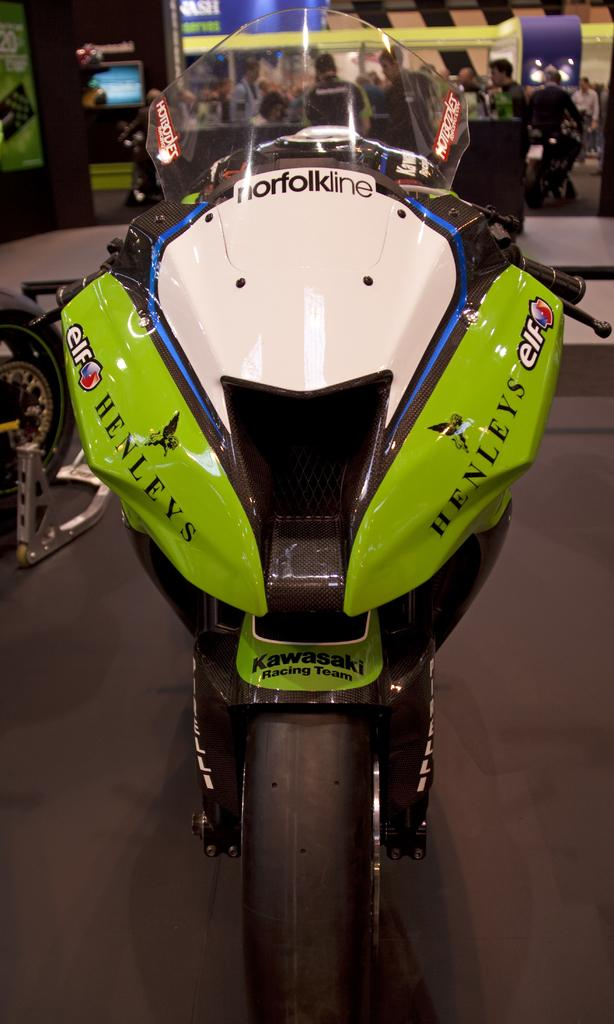What is the main object in the image? There is a bike in the image. What part of a vehicle can be seen in the image? There is a wheel of a vehicle in the image. How many people are present in the image? There are people (few persons) in the image. What is attached to the wall in the image? There is a screen attached to the wall in the image. What type of credit card is being used by the person in the image? There is no credit card or person using a credit card visible in the image. How many thumbs can be seen on the screen in the image? There are no thumbs visible on the screen in the image. 